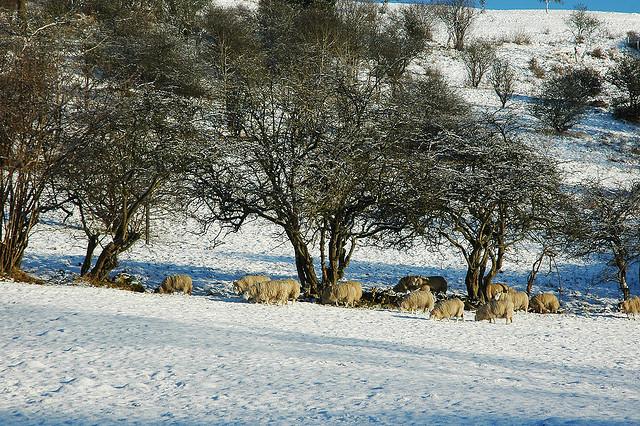Is it summer?
Short answer required. No. What type of plant is pictured?
Give a very brief answer. Tree. What kind of animals are these?
Concise answer only. Sheep. Where are the animals located?
Give a very brief answer. Under trees. 